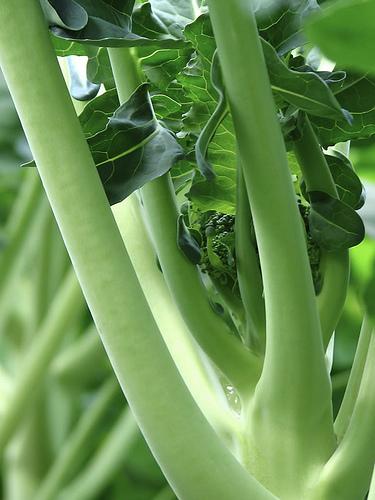Can you eat this plant?
Quick response, please. Yes. Are there any animals?
Answer briefly. No. Is it daytime?
Answer briefly. Yes. 